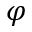<formula> <loc_0><loc_0><loc_500><loc_500>\varphi</formula> 